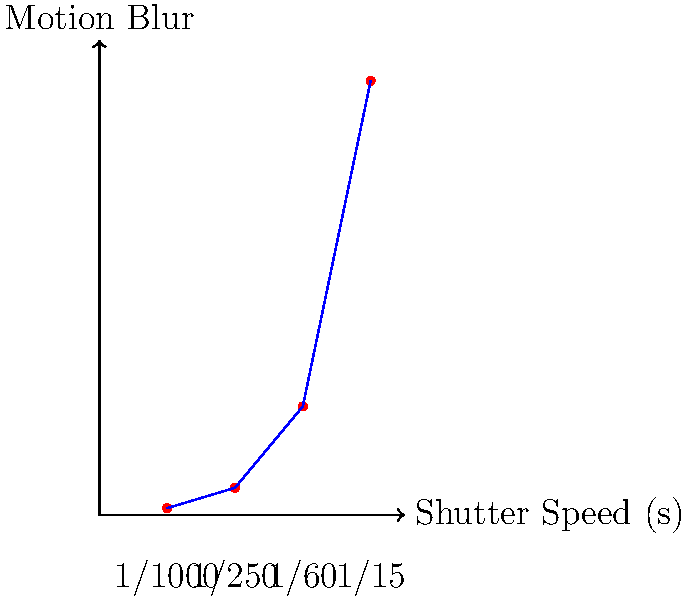Based on the graph showing the relationship between shutter speed and motion blur, which of the following statements is true?

A) As shutter speed increases, motion blur decreases
B) As shutter speed decreases, motion blur decreases
C) There is no correlation between shutter speed and motion blur
D) Motion blur remains constant regardless of shutter speed Let's analyze the graph step-by-step:

1. The x-axis represents shutter speed, increasing from left to right (1/1000s to 1/15s).
2. The y-axis represents motion blur, increasing from bottom to top.
3. We can see that the curve starts low on the left and rises as it moves to the right.

4. At 1/1000s (fastest shutter speed shown), the motion blur is minimal.
5. As we move to slower shutter speeds (1/250s, 1/60s, 1/15s), the motion blur increases.
6. This relationship shows an inverse correlation: as shutter speed decreases (gets slower), motion blur increases.

7. Remember that a faster shutter speed (e.g., 1/1000s) means the shutter is open for a shorter time, allowing less time for movement to be captured, resulting in less blur.
8. Conversely, a slower shutter speed (e.g., 1/15s) means the shutter is open longer, allowing more time for movement to be captured, resulting in more blur.

Therefore, the correct statement is that as shutter speed decreases (gets slower), motion blur increases. This is equivalent to saying that as shutter speed increases (gets faster), motion blur decreases.
Answer: A) As shutter speed increases, motion blur decreases 